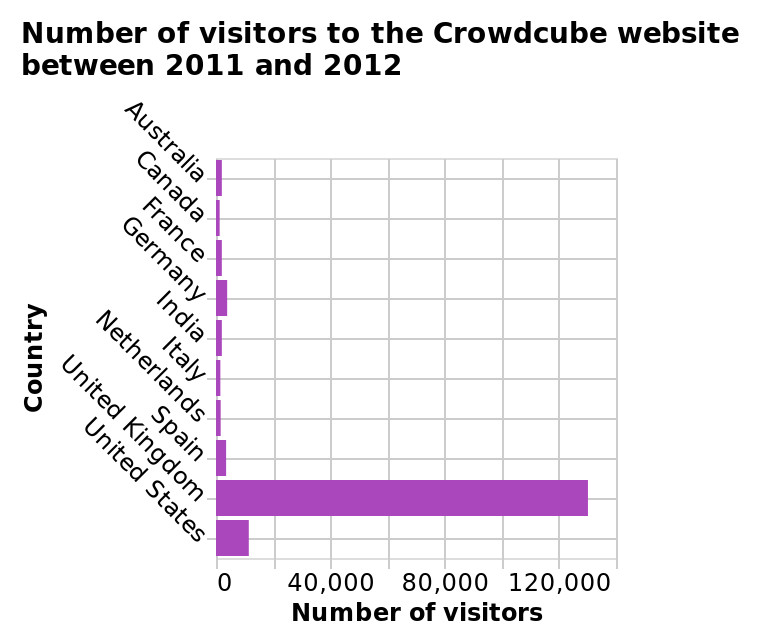<image>
Within which time period does the bar chart represent the number of visitors to the Crowdcube website? The bar chart represents the number of visitors to the Crowdcube website between 2011 and 2012. Did any country have exactly 20,000 visitors according to the traffic data? No, all the countries listed had traffic below 20,000 visitors. What is being measured along the x-axis? The number of visitors to the Crowdcube website is measured along the x-axis. 